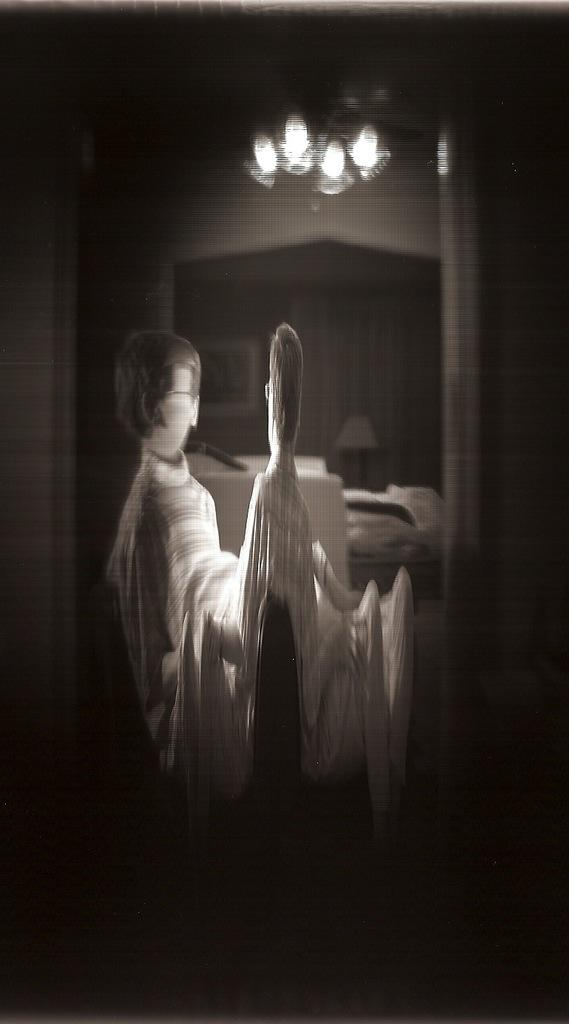What is the main subject in the center of the image? There are cartoons in the center of the image. What can be seen at the top of the image? There are lights at the top of the image. What type of stew is being prepared in the image? There is no stew present in the image; it features cartoons and lights. What kind of treatment is being administered to the cartoon character in the image? There is no treatment being administered to any cartoon character in the image; it only shows cartoons and lights. 